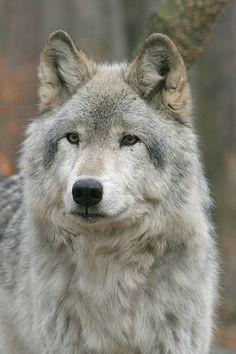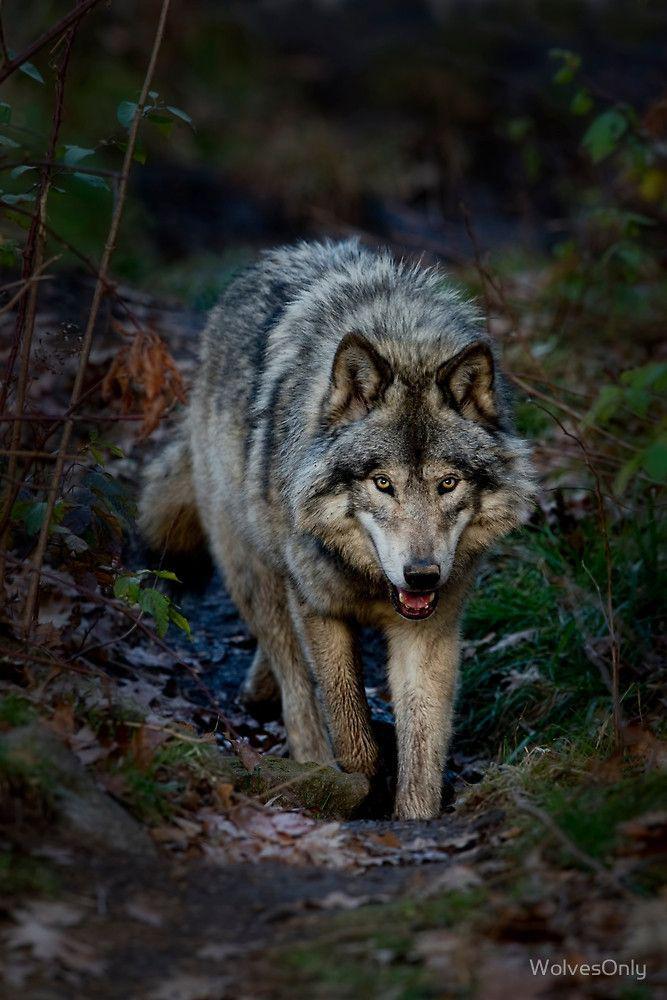The first image is the image on the left, the second image is the image on the right. For the images shown, is this caption "There are more than one animal in the image on the left." true? Answer yes or no. No. 